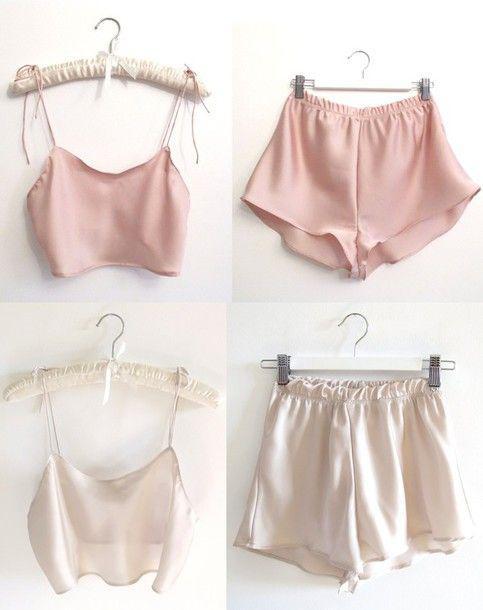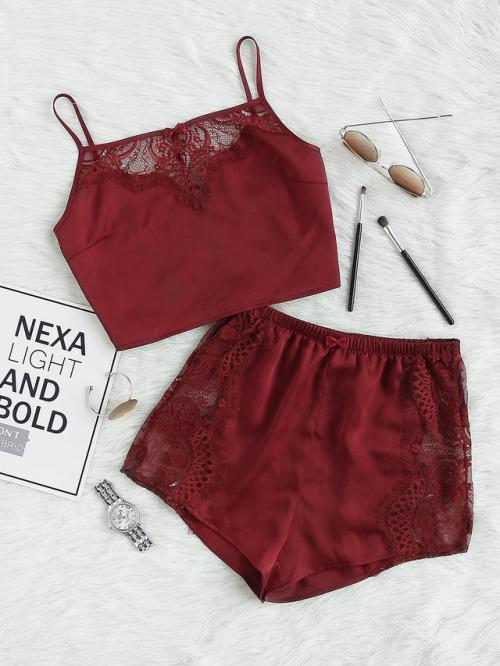The first image is the image on the left, the second image is the image on the right. Analyze the images presented: Is the assertion "the left image has a necklace and shoes" valid? Answer yes or no. No. 